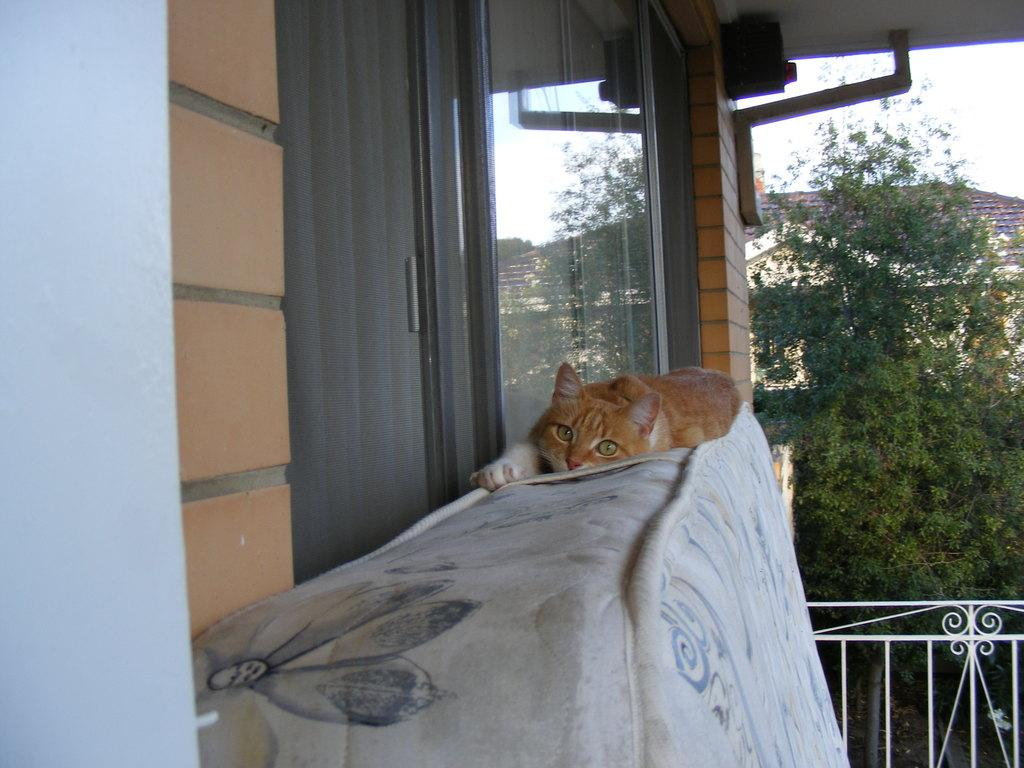What animal can be seen in the image? There is a cat in the image. Where is the cat located? The cat is lying on the bed. What can be seen in the background of the image? There are 2 buildings, a tree, and a fence in the background of the image. Can you touch the sponge in the image? There is no sponge present in the image. What type of branch is the cat holding in the image? There is no branch in the image, and the cat is not holding anything. 